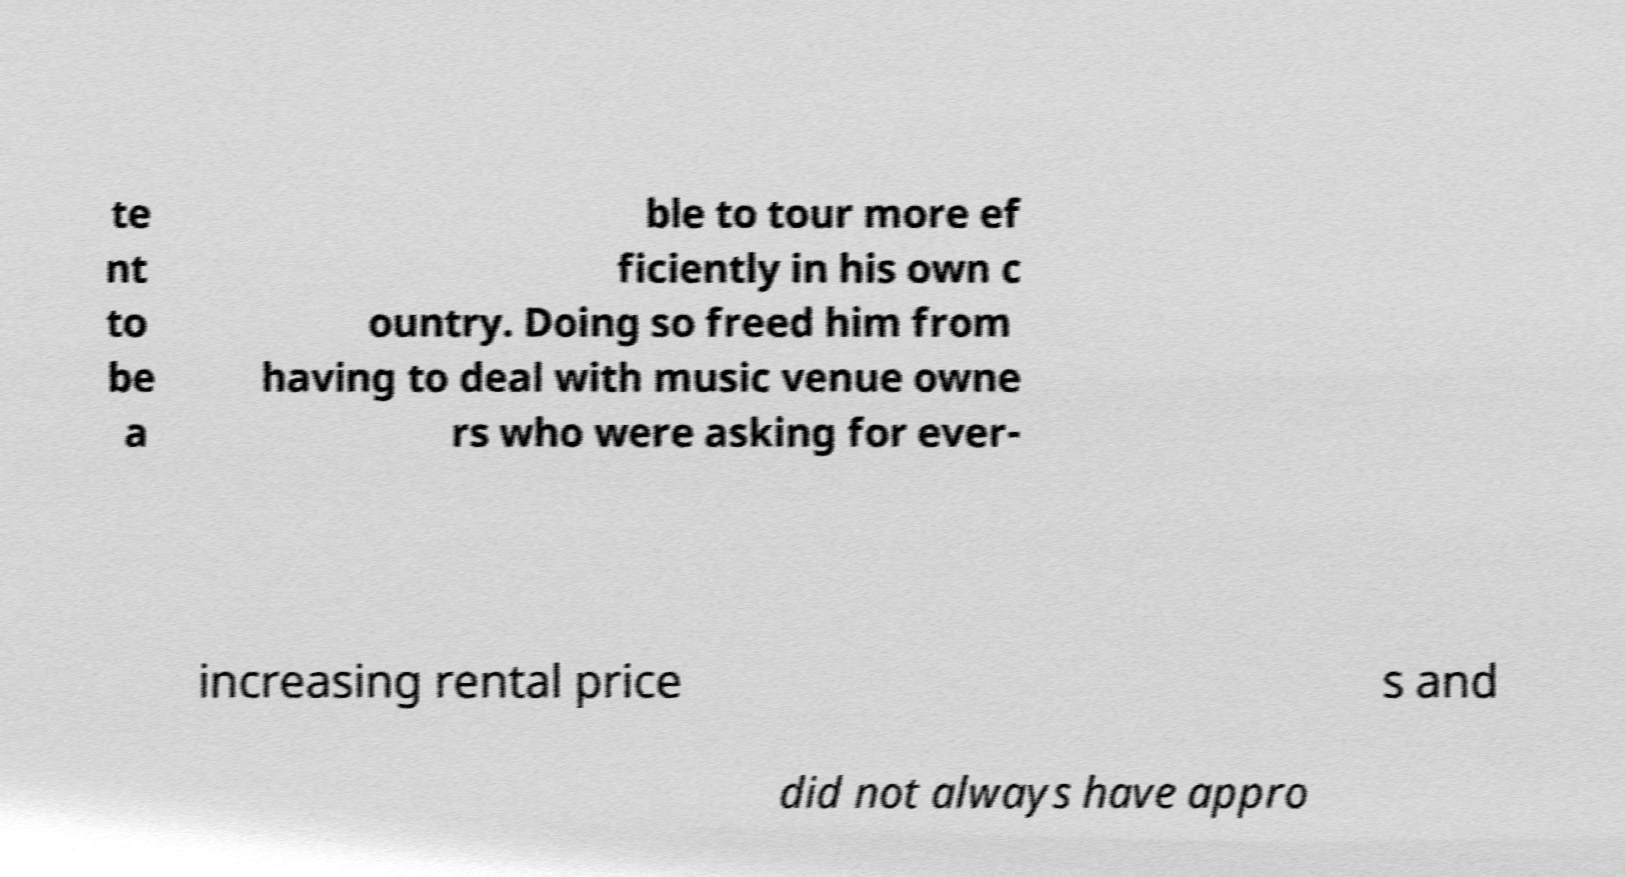For documentation purposes, I need the text within this image transcribed. Could you provide that? te nt to be a ble to tour more ef ficiently in his own c ountry. Doing so freed him from having to deal with music venue owne rs who were asking for ever- increasing rental price s and did not always have appro 